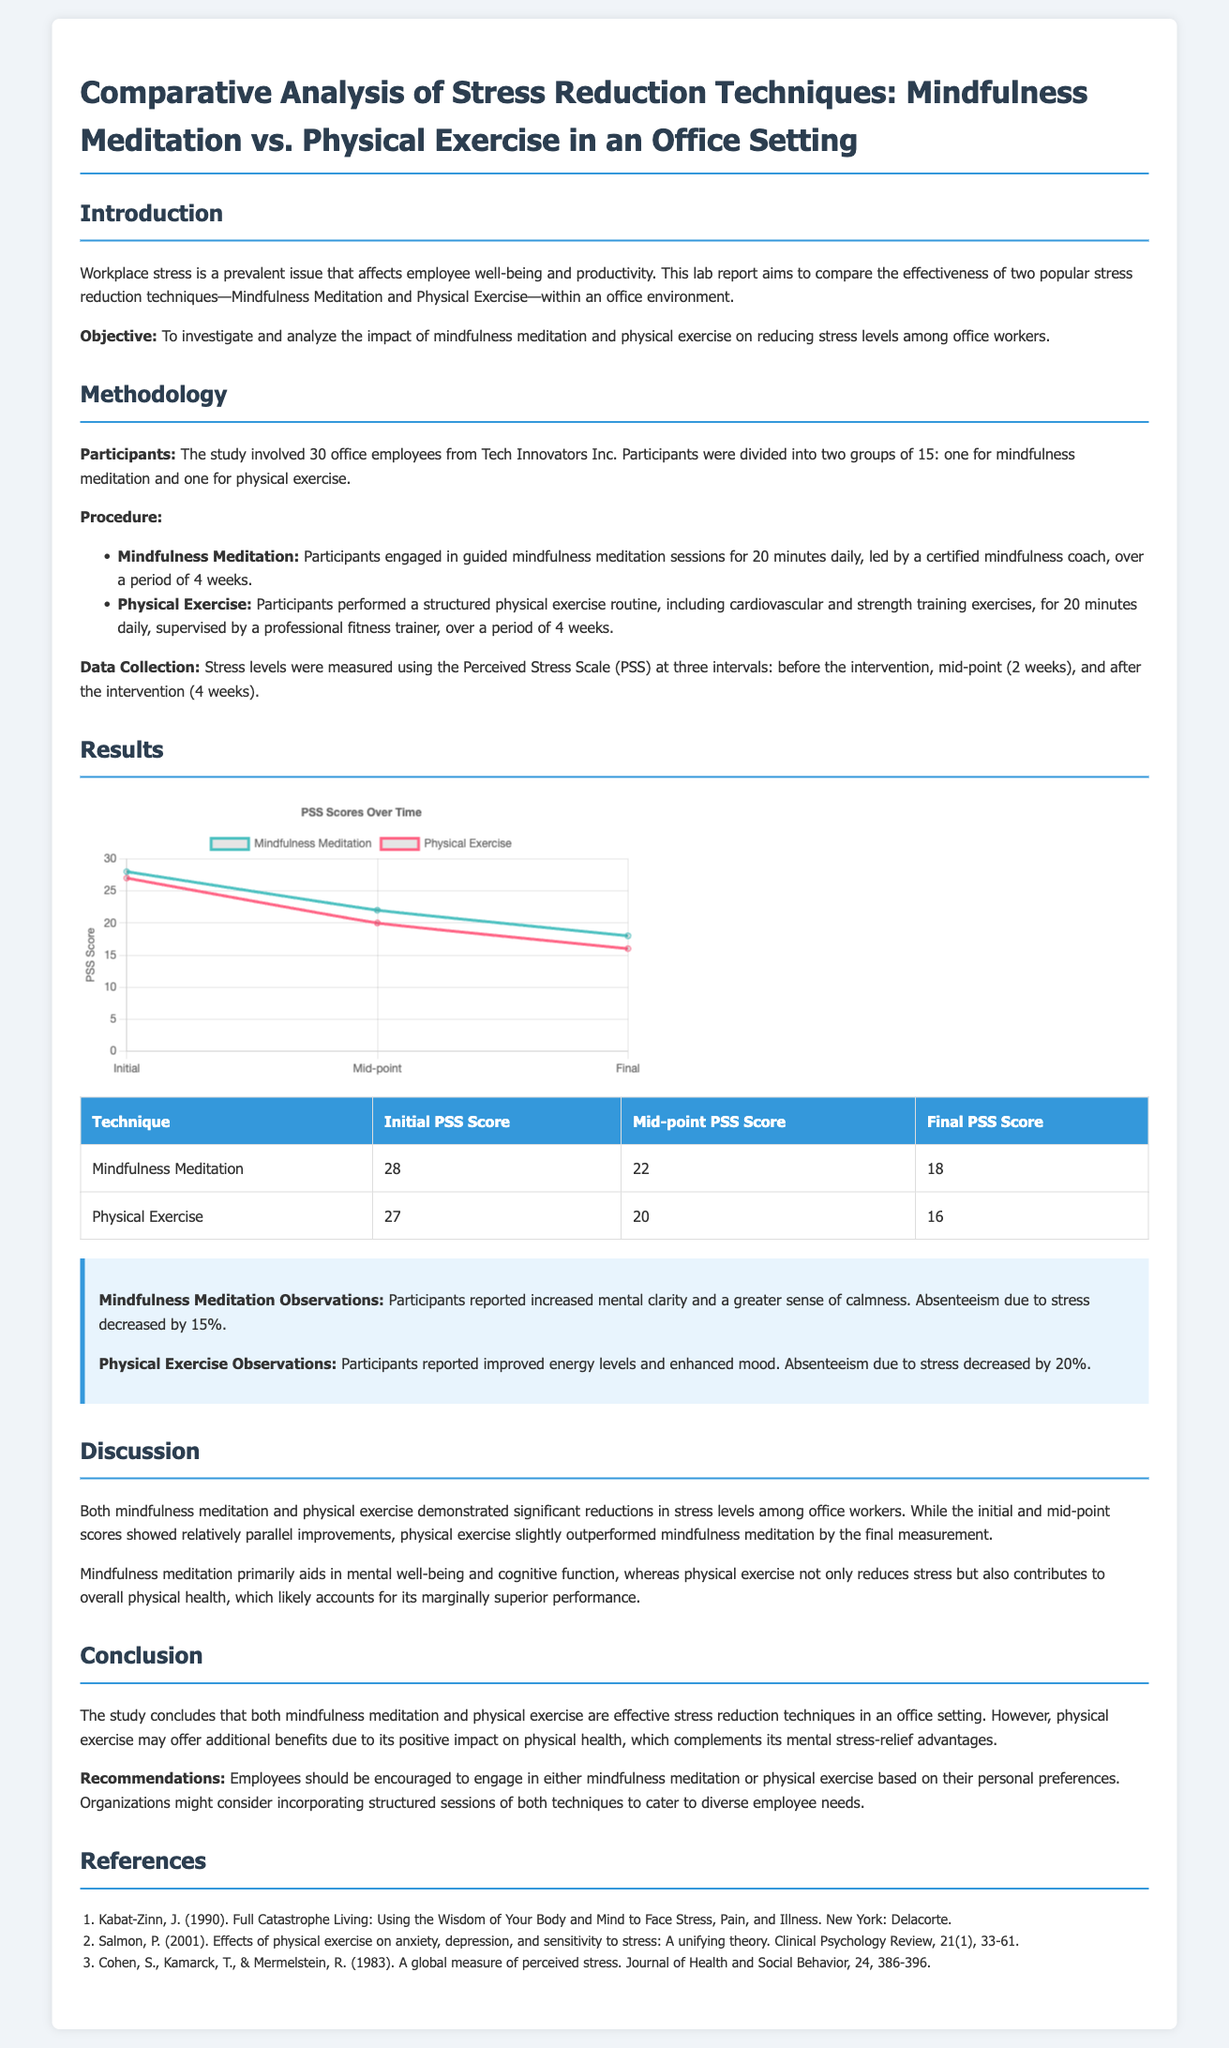What is the primary objective of the study? The objective of the study is to investigate and analyze the impact of mindfulness meditation and physical exercise on reducing stress levels among office workers.
Answer: To investigate and analyze the impact of mindfulness meditation and physical exercise on reducing stress levels among office workers How many participants were involved in the study? The study involved 30 office employees from Tech Innovators Inc.
Answer: 30 What was the initial PSS score for the group practicing Mindfulness Meditation? The initial PSS score for the group practicing Mindfulness Meditation is stated in the results section of the document.
Answer: 28 Which technique saw a greater reduction in absenteeism due to stress? The document states that Physical Exercise led to a decrease in absenteeism due to stress by 20%, while Mindfulness Meditation resulted in a 15% reduction.
Answer: Physical Exercise What did participants report experiencing after engaging in Mindfulness Meditation? The document describes that participants reported increased mental clarity and a greater sense of calmness after engaging in Mindfulness Meditation.
Answer: Increased mental clarity and a greater sense of calmness What does the conclusion suggest about the effectiveness of the two techniques? The conclusion compares the effectiveness of the two techniques, indicating their effectiveness in stress reduction, with a slight edge to physical exercise.
Answer: Both are effective, but physical exercise may offer additional benefits 